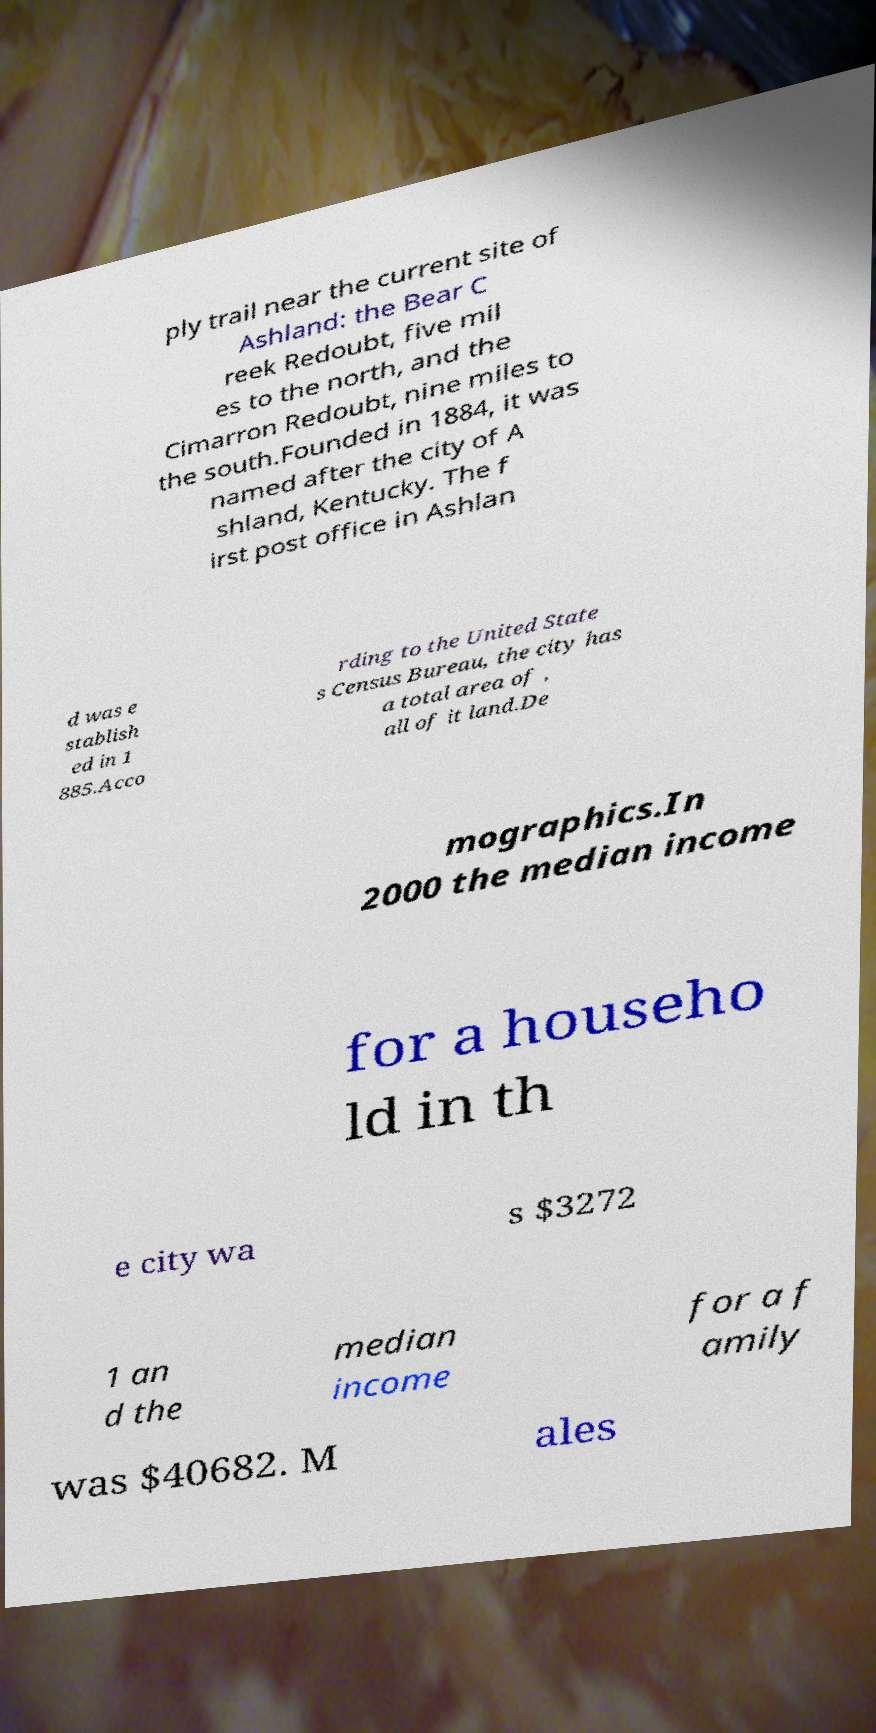What messages or text are displayed in this image? I need them in a readable, typed format. ply trail near the current site of Ashland: the Bear C reek Redoubt, five mil es to the north, and the Cimarron Redoubt, nine miles to the south.Founded in 1884, it was named after the city of A shland, Kentucky. The f irst post office in Ashlan d was e stablish ed in 1 885.Acco rding to the United State s Census Bureau, the city has a total area of , all of it land.De mographics.In 2000 the median income for a househo ld in th e city wa s $3272 1 an d the median income for a f amily was $40682. M ales 